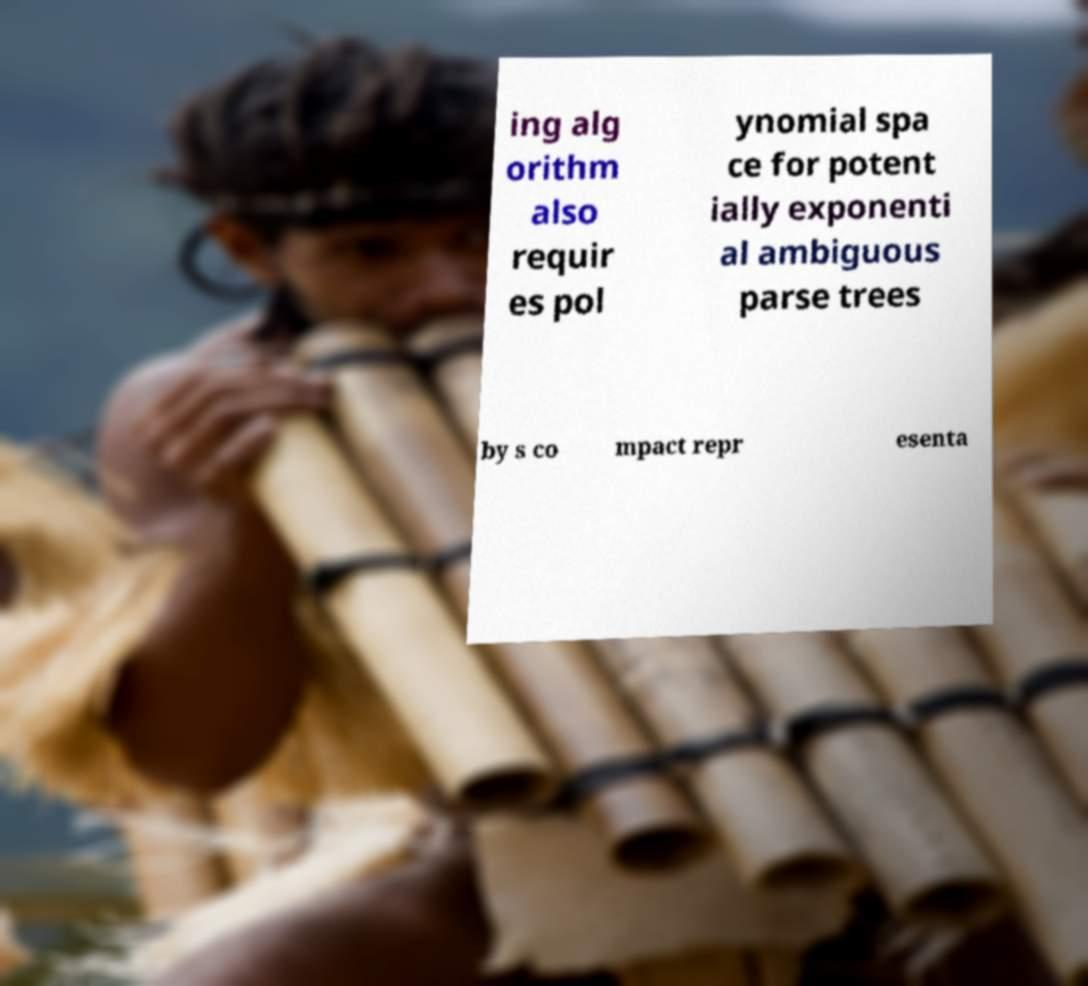What messages or text are displayed in this image? I need them in a readable, typed format. ing alg orithm also requir es pol ynomial spa ce for potent ially exponenti al ambiguous parse trees by s co mpact repr esenta 